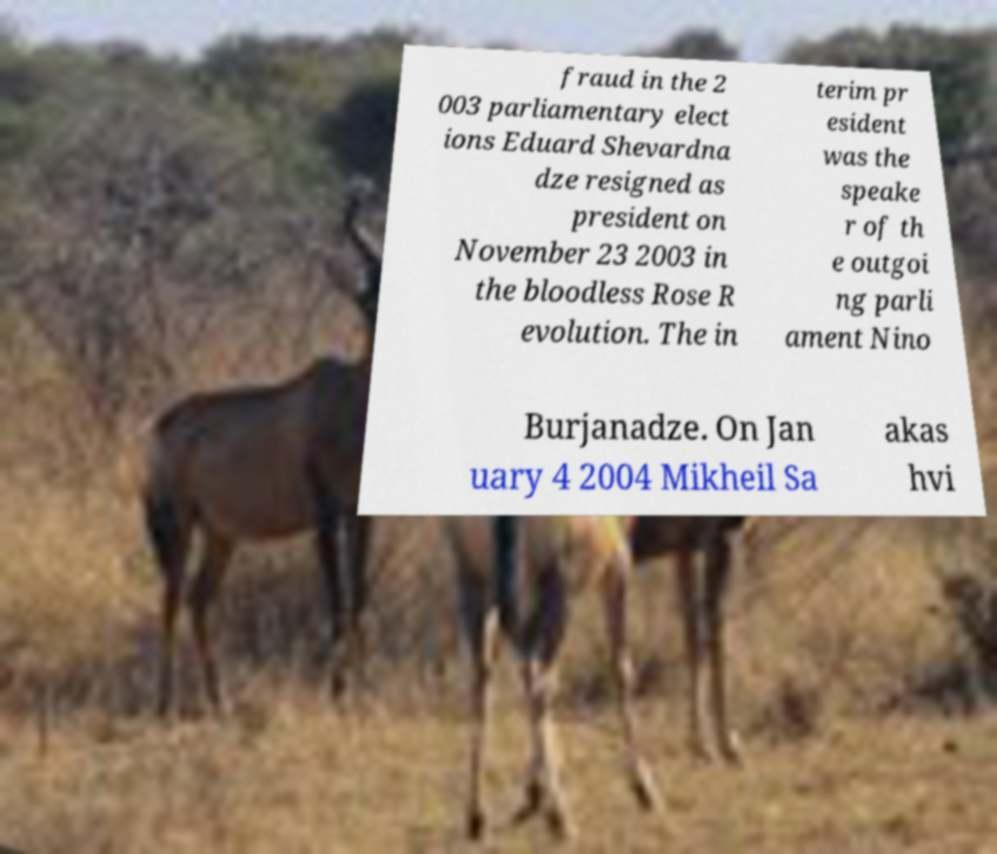For documentation purposes, I need the text within this image transcribed. Could you provide that? fraud in the 2 003 parliamentary elect ions Eduard Shevardna dze resigned as president on November 23 2003 in the bloodless Rose R evolution. The in terim pr esident was the speake r of th e outgoi ng parli ament Nino Burjanadze. On Jan uary 4 2004 Mikheil Sa akas hvi 